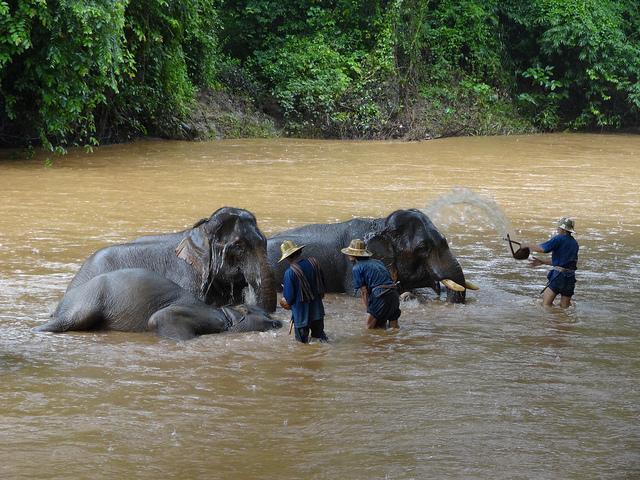Why is the water brown?
From the following four choices, select the correct answer to address the question.
Options: Sand, leeches, dirt, fish. Dirt. What are the people doing to the elephants?
Choose the correct response, then elucidate: 'Answer: answer
Rationale: rationale.'
Options: Hunting, grooming, cooling, feeding. Answer: cooling.
Rationale: They are throwing water on top of them 